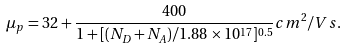Convert formula to latex. <formula><loc_0><loc_0><loc_500><loc_500>\mu _ { p } = 3 2 + \frac { 4 0 0 } { 1 + [ ( N _ { D } + N _ { A } ) / 1 . 8 8 \times 1 0 ^ { 1 7 } ] ^ { 0 . 5 } } c m ^ { 2 } / V s .</formula> 